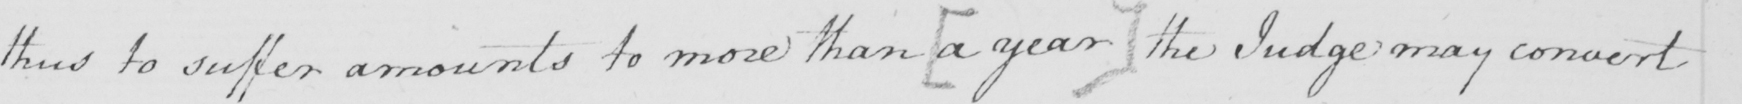Can you read and transcribe this handwriting? thus to suffer amounts to more than  [ a year ]  the Judge may convert 